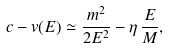<formula> <loc_0><loc_0><loc_500><loc_500>c - v ( E ) \simeq \frac { m ^ { 2 } } { 2 E ^ { 2 } } - \eta \, \frac { E } { M } ,</formula> 